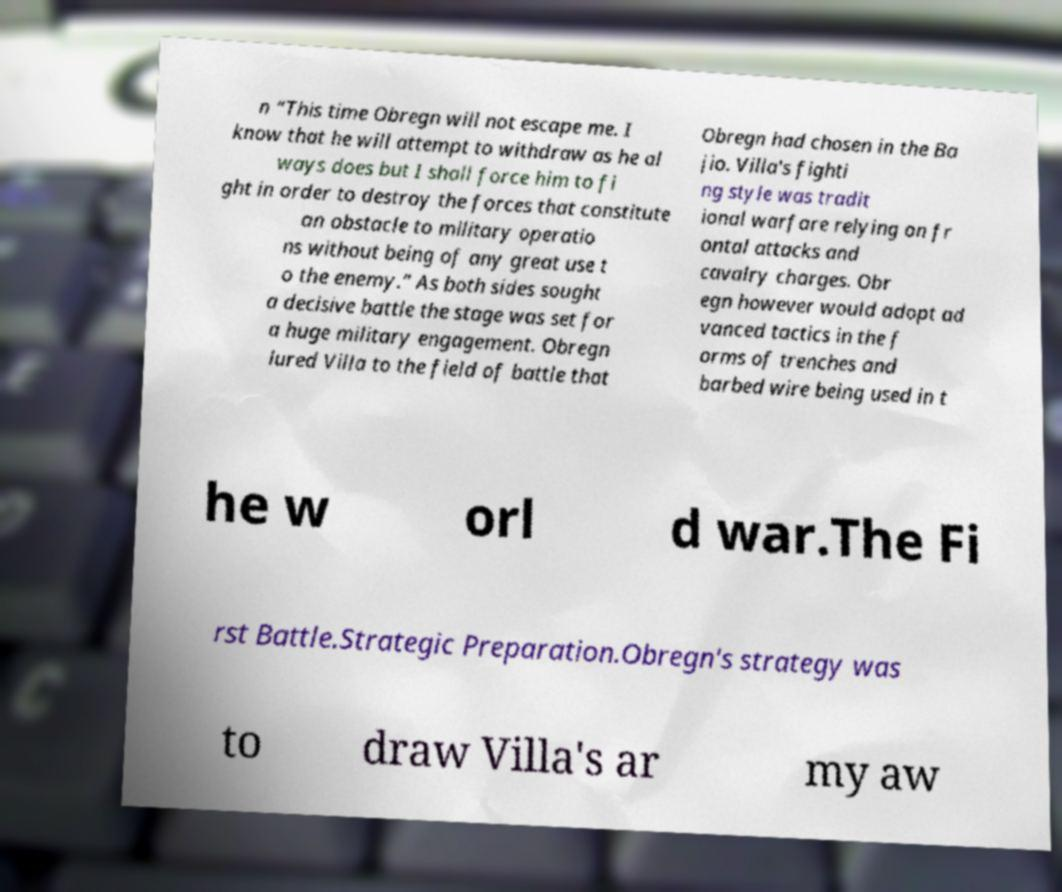There's text embedded in this image that I need extracted. Can you transcribe it verbatim? n “This time Obregn will not escape me. I know that he will attempt to withdraw as he al ways does but I shall force him to fi ght in order to destroy the forces that constitute an obstacle to military operatio ns without being of any great use t o the enemy.” As both sides sought a decisive battle the stage was set for a huge military engagement. Obregn lured Villa to the field of battle that Obregn had chosen in the Ba jio. Villa's fighti ng style was tradit ional warfare relying on fr ontal attacks and cavalry charges. Obr egn however would adopt ad vanced tactics in the f orms of trenches and barbed wire being used in t he w orl d war.The Fi rst Battle.Strategic Preparation.Obregn's strategy was to draw Villa's ar my aw 